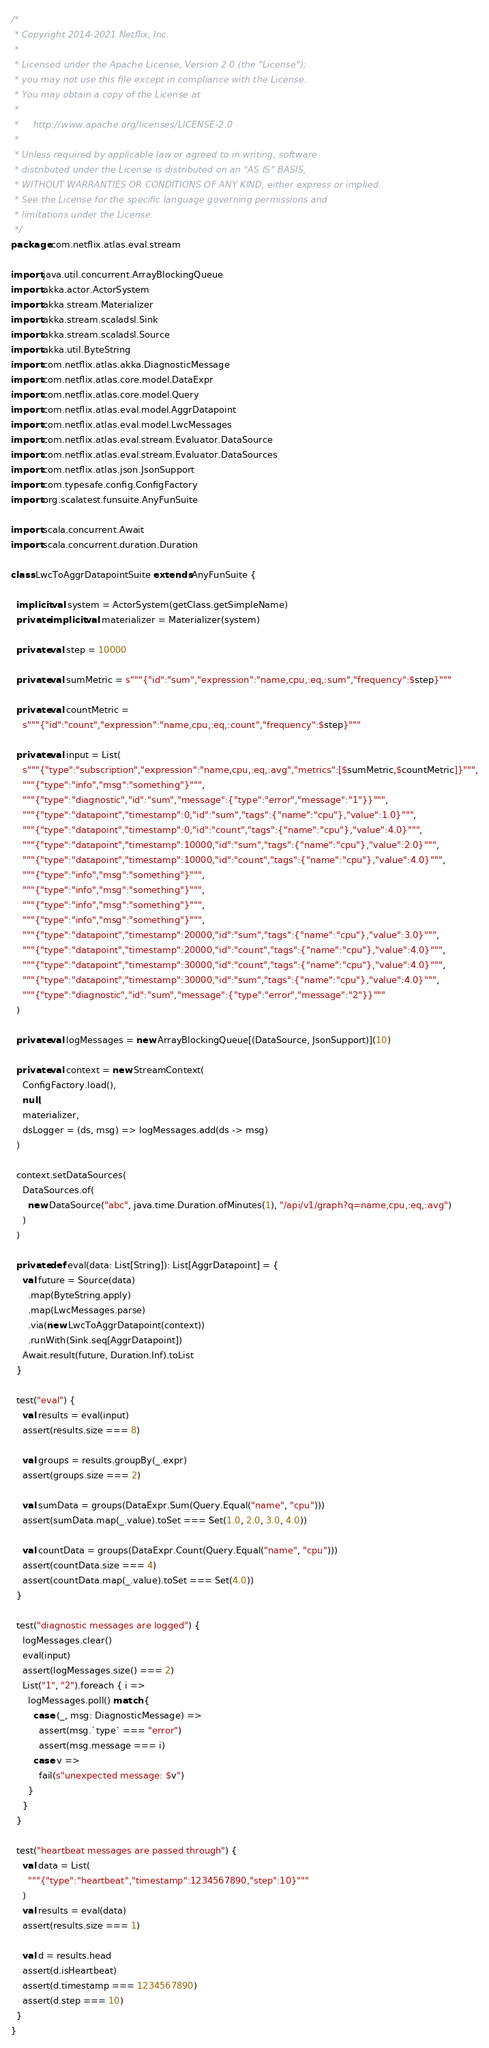Convert code to text. <code><loc_0><loc_0><loc_500><loc_500><_Scala_>/*
 * Copyright 2014-2021 Netflix, Inc.
 *
 * Licensed under the Apache License, Version 2.0 (the "License");
 * you may not use this file except in compliance with the License.
 * You may obtain a copy of the License at
 *
 *     http://www.apache.org/licenses/LICENSE-2.0
 *
 * Unless required by applicable law or agreed to in writing, software
 * distributed under the License is distributed on an "AS IS" BASIS,
 * WITHOUT WARRANTIES OR CONDITIONS OF ANY KIND, either express or implied.
 * See the License for the specific language governing permissions and
 * limitations under the License.
 */
package com.netflix.atlas.eval.stream

import java.util.concurrent.ArrayBlockingQueue
import akka.actor.ActorSystem
import akka.stream.Materializer
import akka.stream.scaladsl.Sink
import akka.stream.scaladsl.Source
import akka.util.ByteString
import com.netflix.atlas.akka.DiagnosticMessage
import com.netflix.atlas.core.model.DataExpr
import com.netflix.atlas.core.model.Query
import com.netflix.atlas.eval.model.AggrDatapoint
import com.netflix.atlas.eval.model.LwcMessages
import com.netflix.atlas.eval.stream.Evaluator.DataSource
import com.netflix.atlas.eval.stream.Evaluator.DataSources
import com.netflix.atlas.json.JsonSupport
import com.typesafe.config.ConfigFactory
import org.scalatest.funsuite.AnyFunSuite

import scala.concurrent.Await
import scala.concurrent.duration.Duration

class LwcToAggrDatapointSuite extends AnyFunSuite {

  implicit val system = ActorSystem(getClass.getSimpleName)
  private implicit val materializer = Materializer(system)

  private val step = 10000

  private val sumMetric = s"""{"id":"sum","expression":"name,cpu,:eq,:sum","frequency":$step}"""

  private val countMetric =
    s"""{"id":"count","expression":"name,cpu,:eq,:count","frequency":$step}"""

  private val input = List(
    s"""{"type":"subscription","expression":"name,cpu,:eq,:avg","metrics":[$sumMetric,$countMetric]}""",
    """{"type":"info","msg":"something"}""",
    """{"type":"diagnostic","id":"sum","message":{"type":"error","message":"1"}}""",
    """{"type":"datapoint","timestamp":0,"id":"sum","tags":{"name":"cpu"},"value":1.0}""",
    """{"type":"datapoint","timestamp":0,"id":"count","tags":{"name":"cpu"},"value":4.0}""",
    """{"type":"datapoint","timestamp":10000,"id":"sum","tags":{"name":"cpu"},"value":2.0}""",
    """{"type":"datapoint","timestamp":10000,"id":"count","tags":{"name":"cpu"},"value":4.0}""",
    """{"type":"info","msg":"something"}""",
    """{"type":"info","msg":"something"}""",
    """{"type":"info","msg":"something"}""",
    """{"type":"info","msg":"something"}""",
    """{"type":"datapoint","timestamp":20000,"id":"sum","tags":{"name":"cpu"},"value":3.0}""",
    """{"type":"datapoint","timestamp":20000,"id":"count","tags":{"name":"cpu"},"value":4.0}""",
    """{"type":"datapoint","timestamp":30000,"id":"count","tags":{"name":"cpu"},"value":4.0}""",
    """{"type":"datapoint","timestamp":30000,"id":"sum","tags":{"name":"cpu"},"value":4.0}""",
    """{"type":"diagnostic","id":"sum","message":{"type":"error","message":"2"}}"""
  )

  private val logMessages = new ArrayBlockingQueue[(DataSource, JsonSupport)](10)

  private val context = new StreamContext(
    ConfigFactory.load(),
    null,
    materializer,
    dsLogger = (ds, msg) => logMessages.add(ds -> msg)
  )

  context.setDataSources(
    DataSources.of(
      new DataSource("abc", java.time.Duration.ofMinutes(1), "/api/v1/graph?q=name,cpu,:eq,:avg")
    )
  )

  private def eval(data: List[String]): List[AggrDatapoint] = {
    val future = Source(data)
      .map(ByteString.apply)
      .map(LwcMessages.parse)
      .via(new LwcToAggrDatapoint(context))
      .runWith(Sink.seq[AggrDatapoint])
    Await.result(future, Duration.Inf).toList
  }

  test("eval") {
    val results = eval(input)
    assert(results.size === 8)

    val groups = results.groupBy(_.expr)
    assert(groups.size === 2)

    val sumData = groups(DataExpr.Sum(Query.Equal("name", "cpu")))
    assert(sumData.map(_.value).toSet === Set(1.0, 2.0, 3.0, 4.0))

    val countData = groups(DataExpr.Count(Query.Equal("name", "cpu")))
    assert(countData.size === 4)
    assert(countData.map(_.value).toSet === Set(4.0))
  }

  test("diagnostic messages are logged") {
    logMessages.clear()
    eval(input)
    assert(logMessages.size() === 2)
    List("1", "2").foreach { i =>
      logMessages.poll() match {
        case (_, msg: DiagnosticMessage) =>
          assert(msg.`type` === "error")
          assert(msg.message === i)
        case v =>
          fail(s"unexpected message: $v")
      }
    }
  }

  test("heartbeat messages are passed through") {
    val data = List(
      """{"type":"heartbeat","timestamp":1234567890,"step":10}"""
    )
    val results = eval(data)
    assert(results.size === 1)

    val d = results.head
    assert(d.isHeartbeat)
    assert(d.timestamp === 1234567890)
    assert(d.step === 10)
  }
}
</code> 